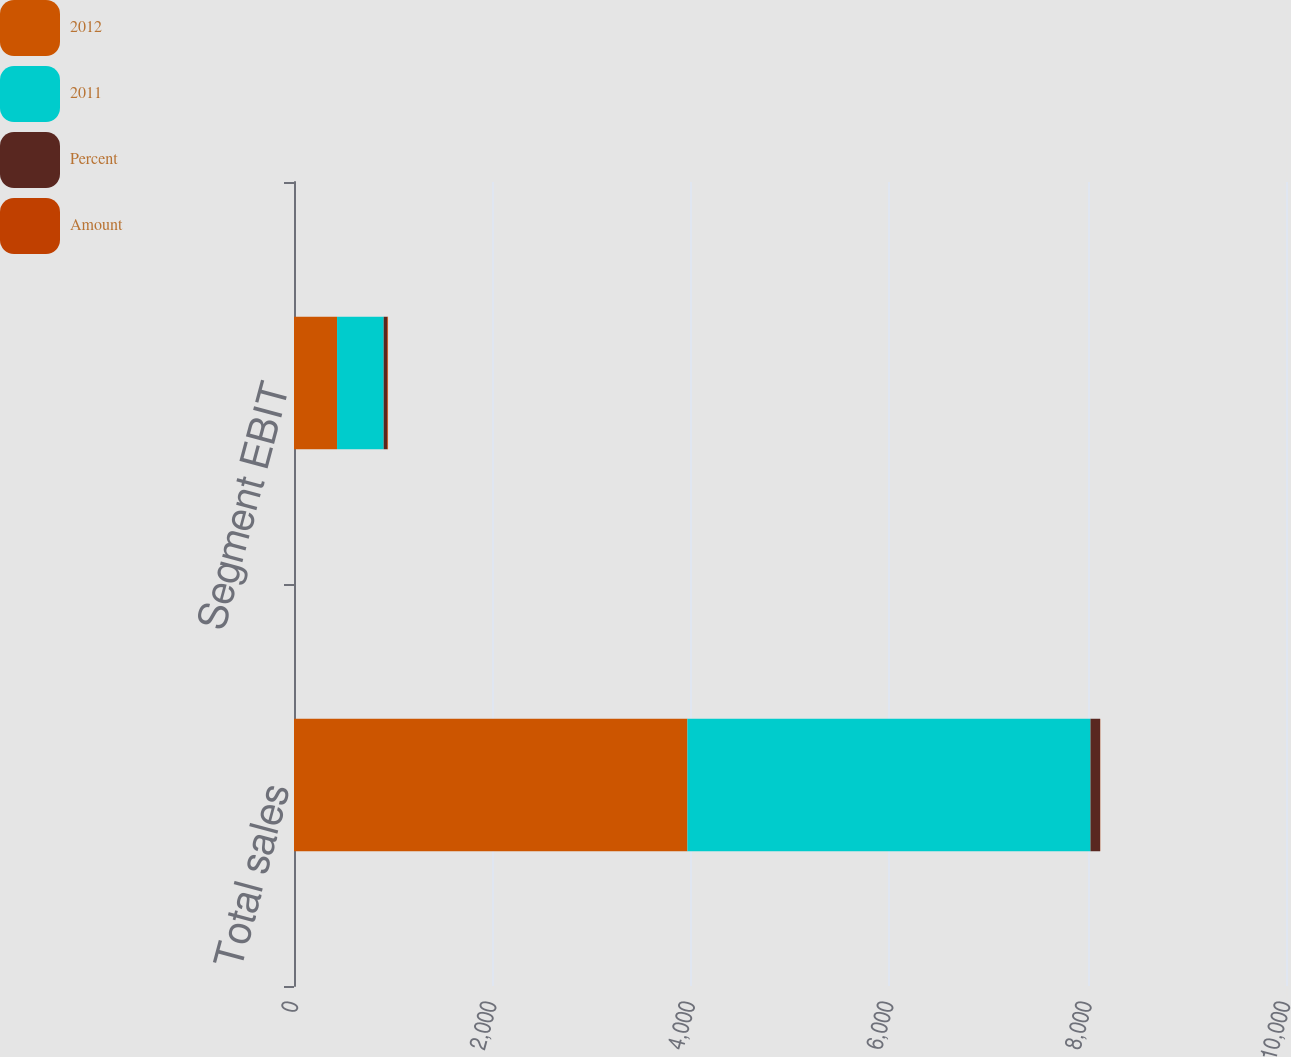Convert chart to OTSL. <chart><loc_0><loc_0><loc_500><loc_500><stacked_bar_chart><ecel><fcel>Total sales<fcel>Segment EBIT<nl><fcel>2012<fcel>3966<fcel>434<nl><fcel>2011<fcel>4063<fcel>470<nl><fcel>Percent<fcel>97<fcel>36<nl><fcel>Amount<fcel>2<fcel>8<nl></chart> 